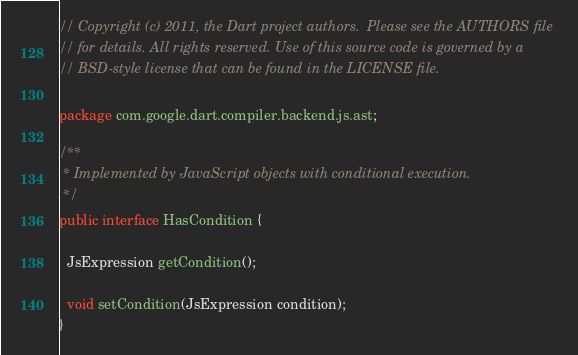Convert code to text. <code><loc_0><loc_0><loc_500><loc_500><_Java_>// Copyright (c) 2011, the Dart project authors.  Please see the AUTHORS file
// for details. All rights reserved. Use of this source code is governed by a
// BSD-style license that can be found in the LICENSE file.

package com.google.dart.compiler.backend.js.ast;

/**
 * Implemented by JavaScript objects with conditional execution.
 */
public interface HasCondition {

  JsExpression getCondition();

  void setCondition(JsExpression condition);
}
</code> 